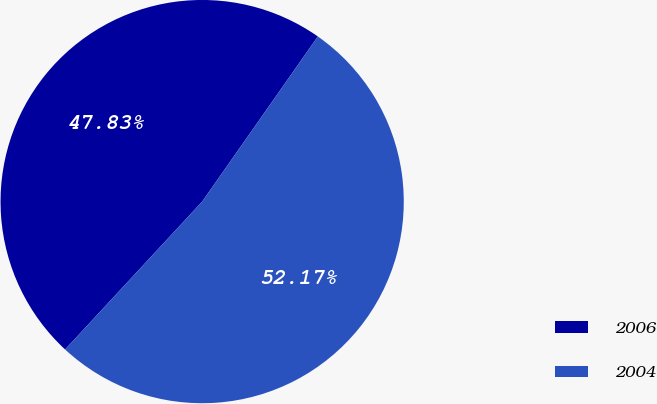Convert chart. <chart><loc_0><loc_0><loc_500><loc_500><pie_chart><fcel>2006<fcel>2004<nl><fcel>47.83%<fcel>52.17%<nl></chart> 